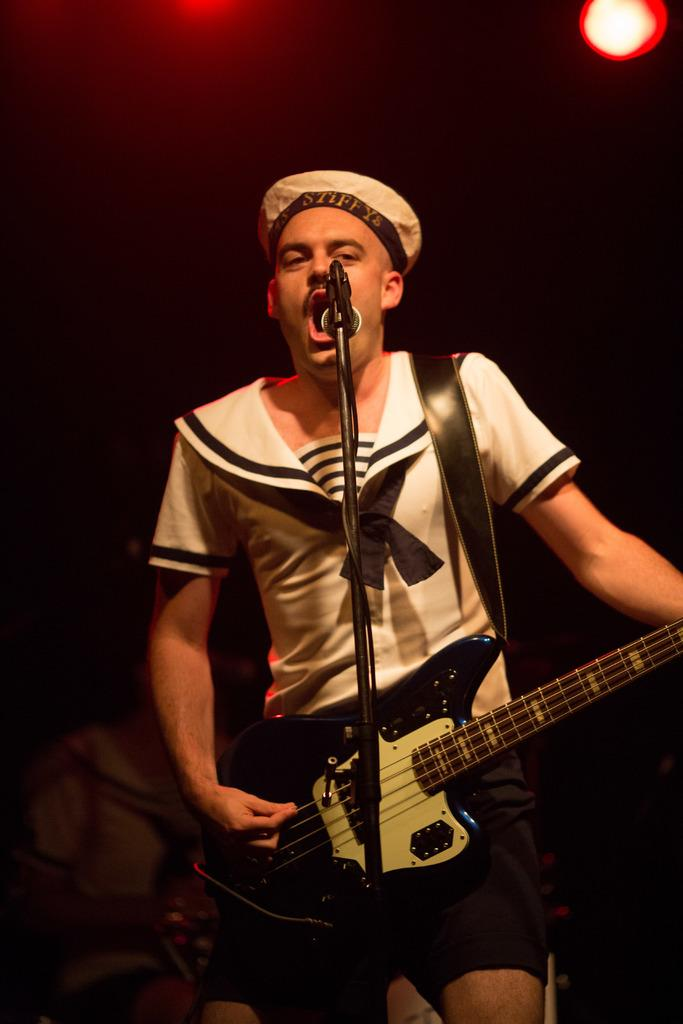What is the man in the image doing? The man is playing a guitar in the image. What object is in front of the man? There is a microphone with a stand in front of the man. How would you describe the lighting in the background of the image? The background of the image is dark, but there is a focusing light visible. Can you see any other people in the image? Yes, there is a person visible in the background. What type of rifle is the man holding while playing the guitar in the image? There is no rifle present in the image; the man is playing a guitar and there is a microphone with a stand in front of him. 